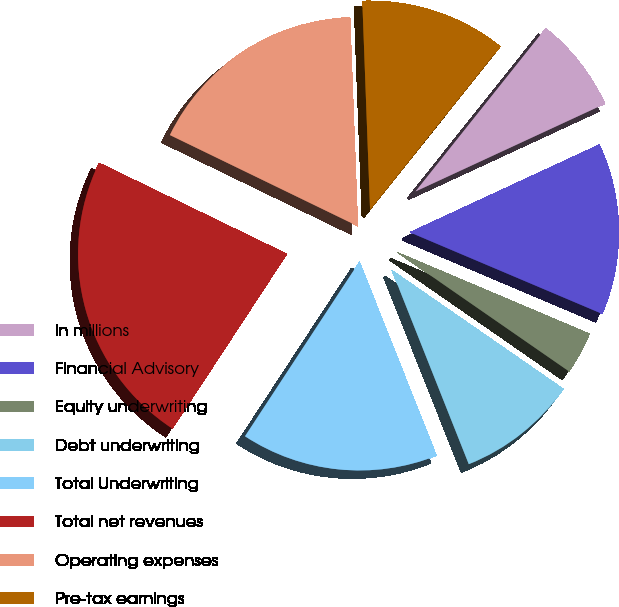Convert chart. <chart><loc_0><loc_0><loc_500><loc_500><pie_chart><fcel>in millions<fcel>Financial Advisory<fcel>Equity underwriting<fcel>Debt underwriting<fcel>Total Underwriting<fcel>Total net revenues<fcel>Operating expenses<fcel>Pre-tax earnings<nl><fcel>7.38%<fcel>13.28%<fcel>3.26%<fcel>9.34%<fcel>15.25%<fcel>22.95%<fcel>17.22%<fcel>11.31%<nl></chart> 